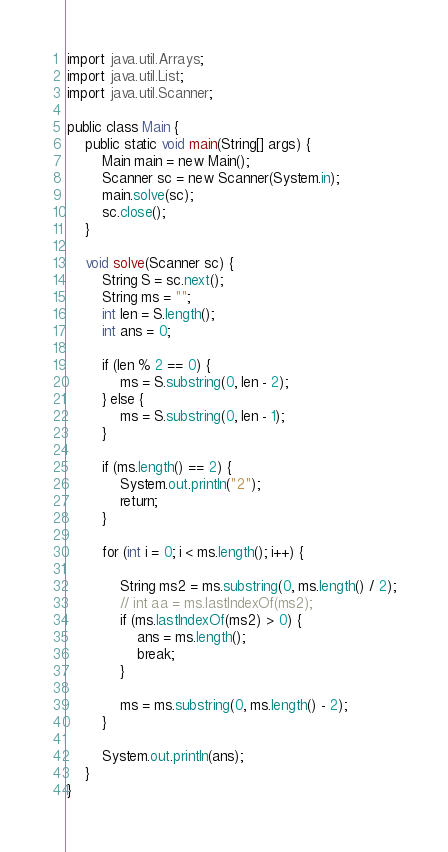Convert code to text. <code><loc_0><loc_0><loc_500><loc_500><_Java_>import java.util.Arrays;
import java.util.List;
import java.util.Scanner;

public class Main {
	public static void main(String[] args) {
		Main main = new Main();
		Scanner sc = new Scanner(System.in);
		main.solve(sc);
		sc.close();
	}

	void solve(Scanner sc) {
		String S = sc.next();
		String ms = "";
		int len = S.length();
		int ans = 0;

		if (len % 2 == 0) {
			ms = S.substring(0, len - 2);
		} else {
			ms = S.substring(0, len - 1);
		}

		if (ms.length() == 2) {
			System.out.println("2");
			return;
		}

		for (int i = 0; i < ms.length(); i++) {

			String ms2 = ms.substring(0, ms.length() / 2);
			// int aa = ms.lastIndexOf(ms2);
			if (ms.lastIndexOf(ms2) > 0) {
				ans = ms.length();
				break;
			}

			ms = ms.substring(0, ms.length() - 2);
		}

		System.out.println(ans);
	}
}</code> 